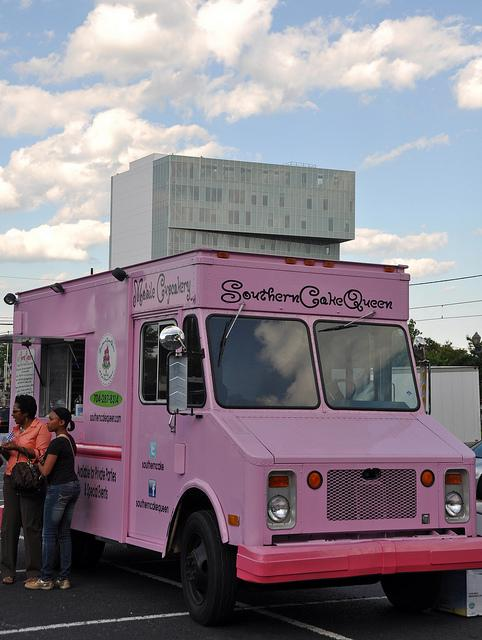If this truck sold food the same color that the truck is what food would it sell? Please explain your reasoning. watermelon. The fruit is red or pink in the center, just like the truck. 